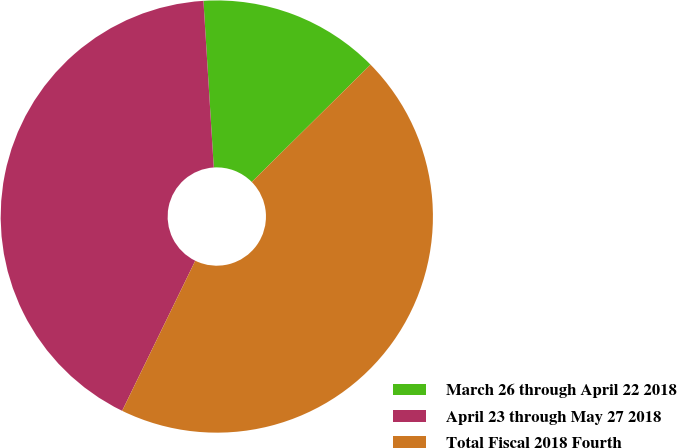Convert chart. <chart><loc_0><loc_0><loc_500><loc_500><pie_chart><fcel>March 26 through April 22 2018<fcel>April 23 through May 27 2018<fcel>Total Fiscal 2018 Fourth<nl><fcel>13.58%<fcel>41.8%<fcel>44.62%<nl></chart> 